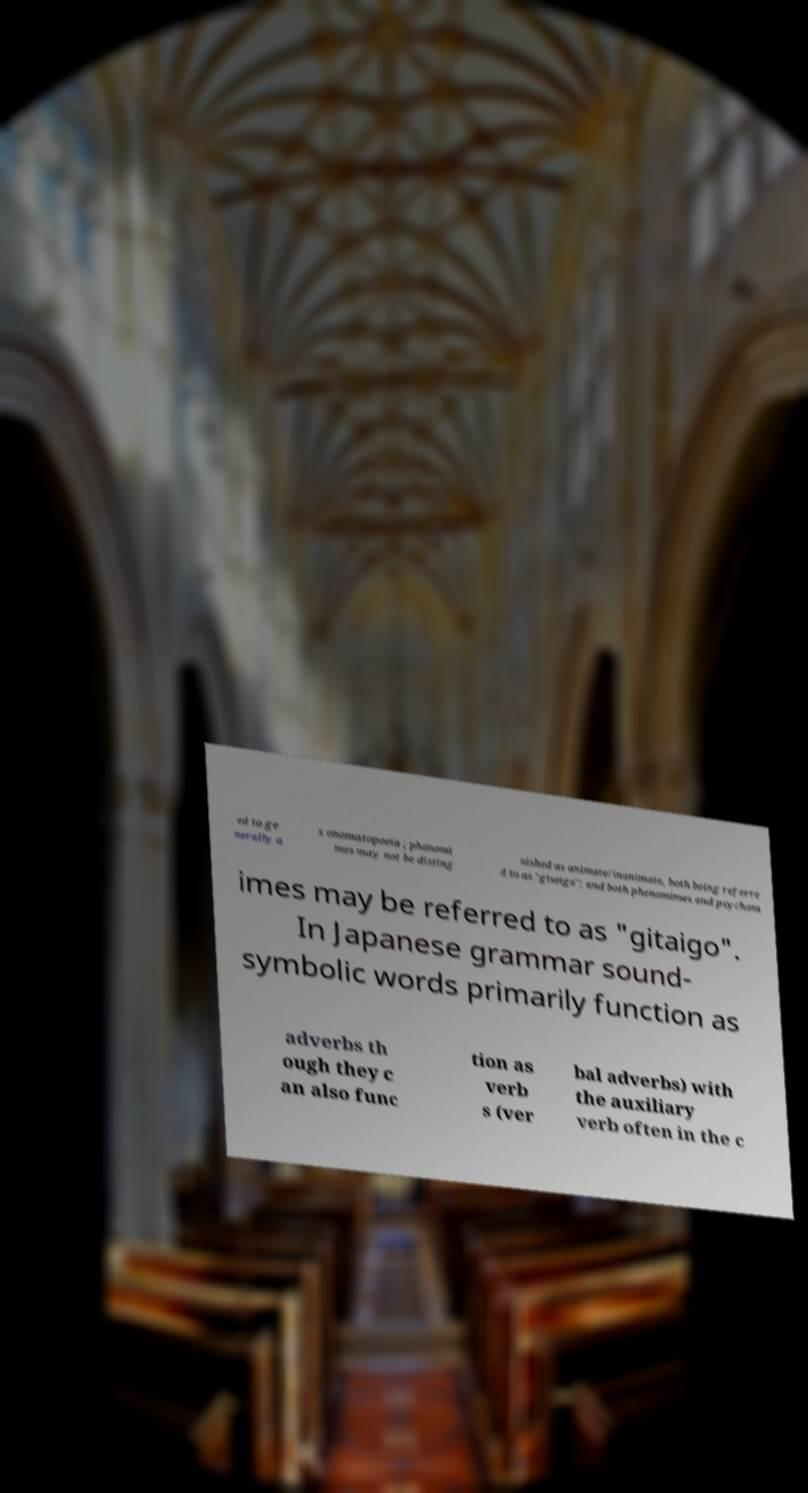There's text embedded in this image that I need extracted. Can you transcribe it verbatim? ed to ge nerally a s onomatopoeia ; phonomi mes may not be disting uished as animate/inanimate, both being referre d to as "giseigo"; and both phenomimes and psychom imes may be referred to as "gitaigo". In Japanese grammar sound- symbolic words primarily function as adverbs th ough they c an also func tion as verb s (ver bal adverbs) with the auxiliary verb often in the c 